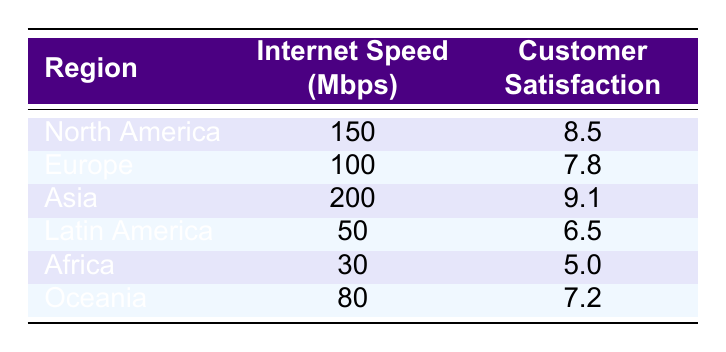What is the internet speed in Asia? According to the table, the value listed under Asia for internet speed is 200 Mbps.
Answer: 200 Mbps Which region has the highest customer satisfaction rating? The highest customer satisfaction rating in the table is 9.1, which corresponds to Asia.
Answer: Asia What is the average internet speed of North America and Europe? For North America, the internet speed is 150 Mbps, and for Europe, it is 100 Mbps. The average is calculated as (150 + 100) / 2 = 125 Mbps.
Answer: 125 Mbps Is customer satisfaction in Oceania higher than in Africa? The customer satisfaction rating for Oceania is 7.2, while for Africa, it is 5.0. Therefore, 7.2 > 5.0 means the statement is true.
Answer: Yes What is the difference in customer satisfaction between Asia and Latin America? The customer satisfaction rating for Asia is 9.1, and for Latin America, it is 6.5. The difference is calculated as 9.1 - 6.5 = 2.6.
Answer: 2.6 Which region has an internet speed below 100 Mbps? The regions listed with internet speeds below 100 Mbps are Latin America at 50 Mbps and Africa at 30 Mbps.
Answer: Latin America, Africa What is the sum of customer satisfaction ratings for all regions? Adding the customer satisfaction ratings: 8.5 (North America) + 7.8 (Europe) + 9.1 (Asia) + 6.5 (Latin America) + 5.0 (Africa) + 7.2 (Oceania) = 44.1.
Answer: 44.1 Is there a region with an internet speed of 80 Mbps? Yes, the region listed with an internet speed of 80 Mbps is Oceania.
Answer: Yes What is the median customer satisfaction rating among all regions? Sorting the customer satisfaction ratings: 5.0, 6.5, 7.2, 7.8, 8.5, 9.1. The median (average of 7.2 and 7.8) = (7.2 + 7.8) / 2 = 7.5.
Answer: 7.5 